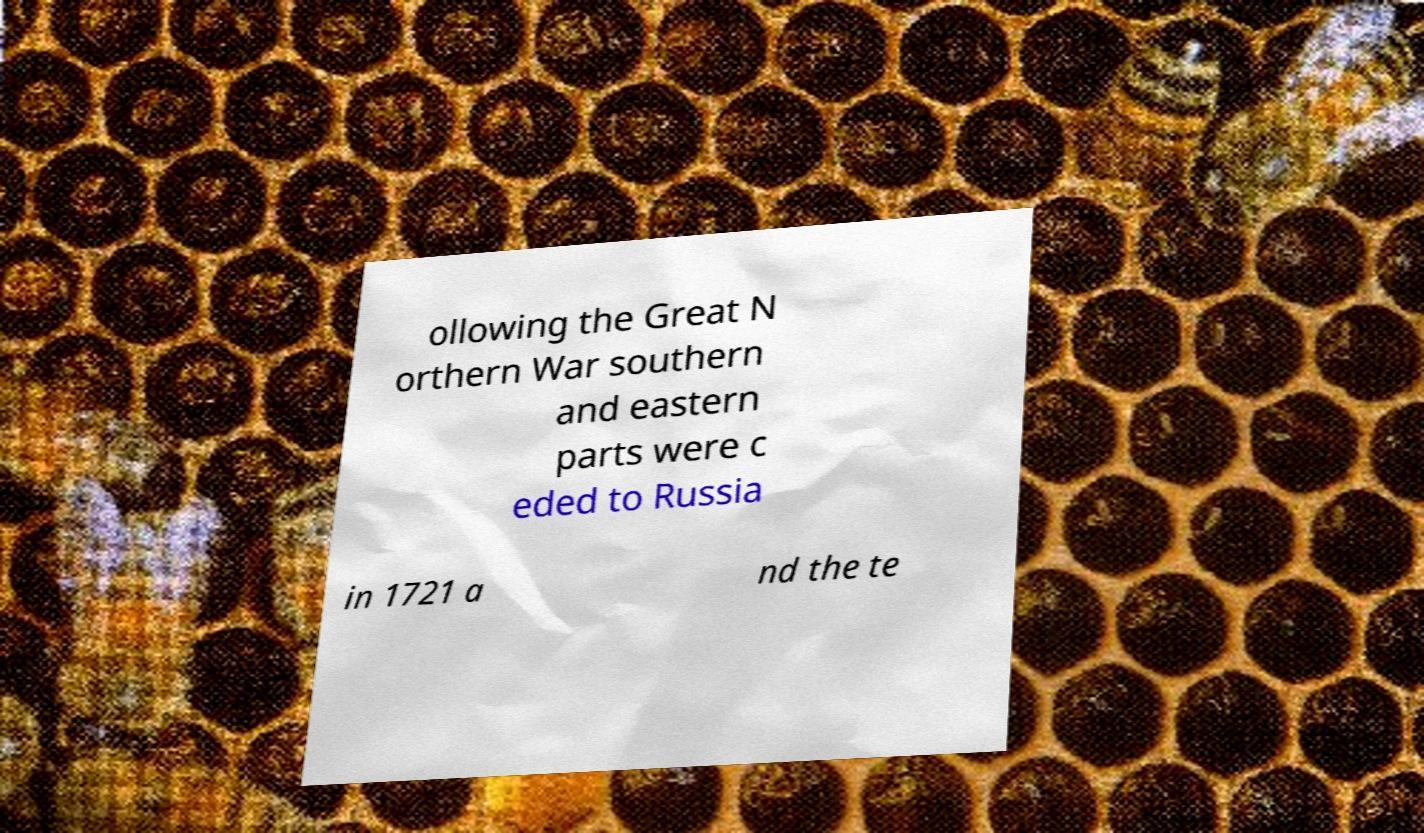I need the written content from this picture converted into text. Can you do that? ollowing the Great N orthern War southern and eastern parts were c eded to Russia in 1721 a nd the te 